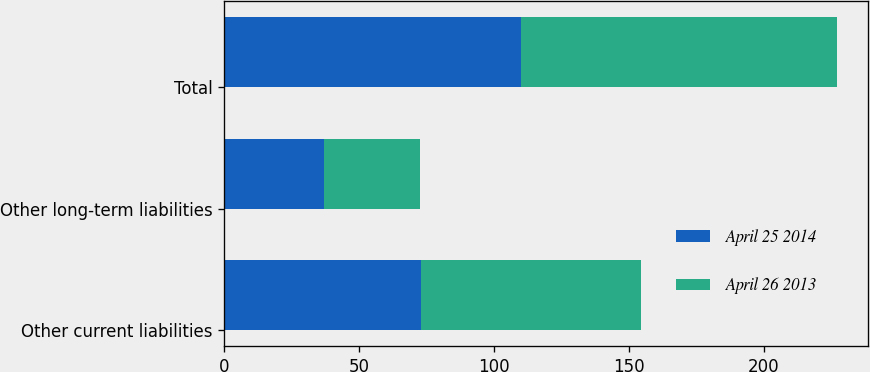Convert chart. <chart><loc_0><loc_0><loc_500><loc_500><stacked_bar_chart><ecel><fcel>Other current liabilities<fcel>Other long-term liabilities<fcel>Total<nl><fcel>April 25 2014<fcel>73<fcel>37<fcel>110<nl><fcel>April 26 2013<fcel>81.6<fcel>35.6<fcel>117.2<nl></chart> 